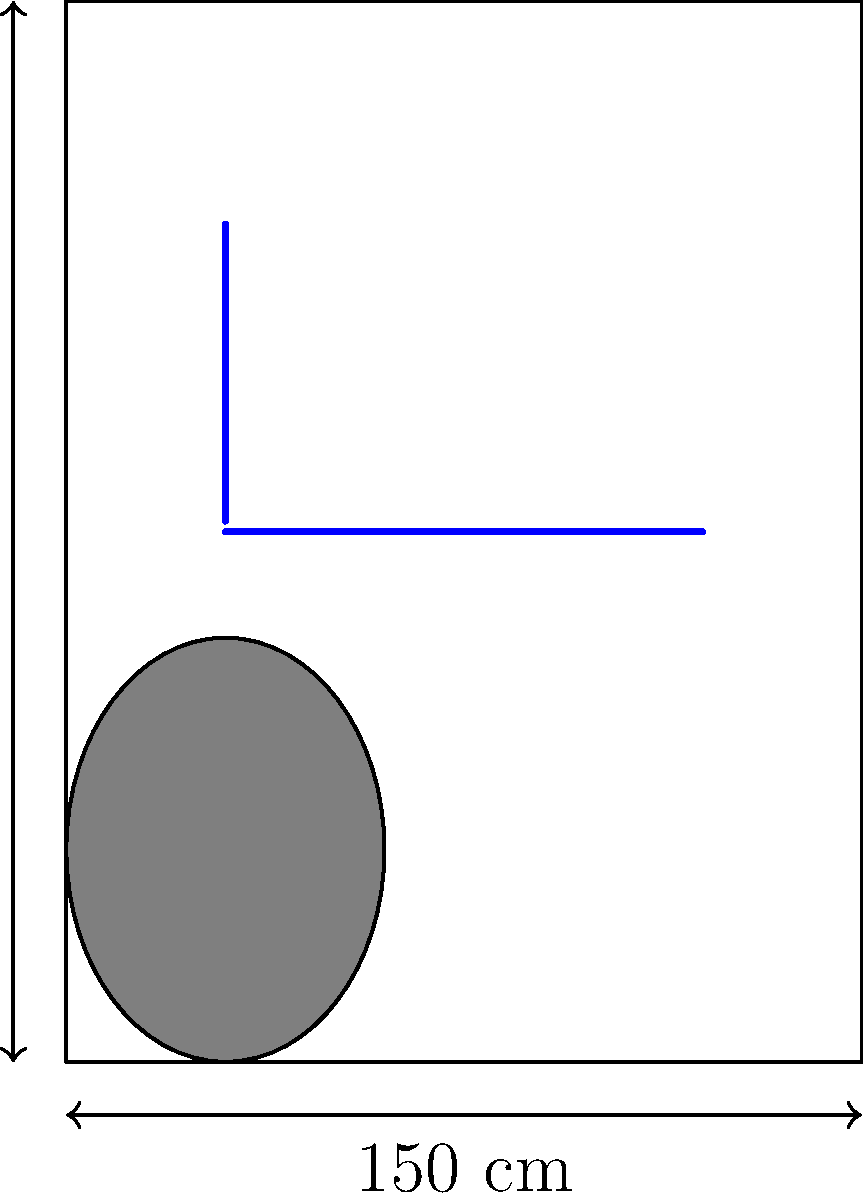In designing an accessible bathroom for a person with limited mobility, what is the minimum recommended width for the bathroom, and at what height should the horizontal grab bar be installed near the toilet? To design an accessible bathroom for someone with limited mobility, like a person who recently injured their knee, we need to consider several factors:

1. Minimum bathroom width:
   The Americans with Disabilities Act (ADA) recommends a minimum clear floor space of 150 cm (60 inches) in width for accessible bathrooms. This allows enough space for wheelchair maneuverability and assistance if needed.

2. Grab bar placement:
   Grab bars are essential for safety and support. The ADA guidelines specify:

   a) Horizontal grab bar:
      - Should be installed on the wall closest to the toilet
      - Height: 83.8 cm to 91.4 cm (33 to 36 inches) above the floor
      - We typically use 86.4 cm (34 inches) as a standard height

   b) Side grab bar:
      - Should be installed on the side wall nearest to the toilet
      - Height: Same as the horizontal grab bar

3. Other considerations:
   - Toilet height: 43.2 cm to 48.3 cm (17 to 19 inches) from floor to top of the seat
   - Clear floor space: At least 76.2 cm x 121.9 cm (30 x 48 inches) in front of the toilet

The diagram shows a bathroom layout with these specifications, including the 150 cm width and the placement of grab bars.
Answer: Minimum width: 150 cm; Horizontal grab bar height: 86.4 cm 